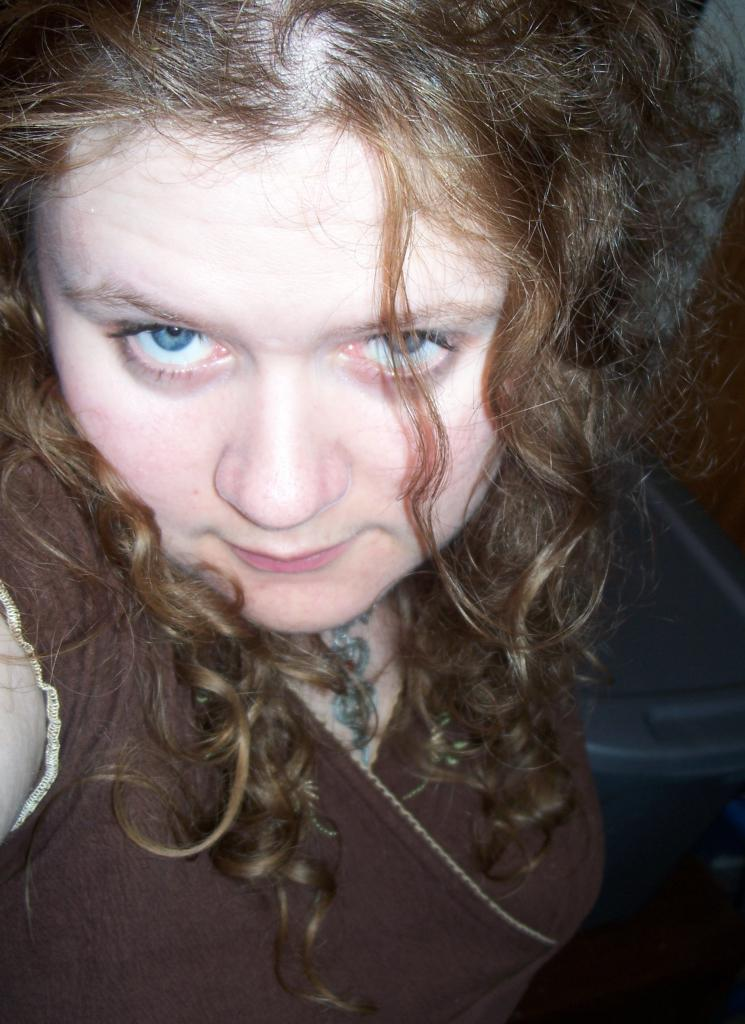Who is the main subject in the image? There is a woman in the image. What is the woman wearing? The woman is wearing a brown dress. What other object can be seen in the image? There is a plastic box visible in the image. What type of ground can be seen beneath the woman in the image? There is no ground visible in the image; it appears to be an indoor setting. 